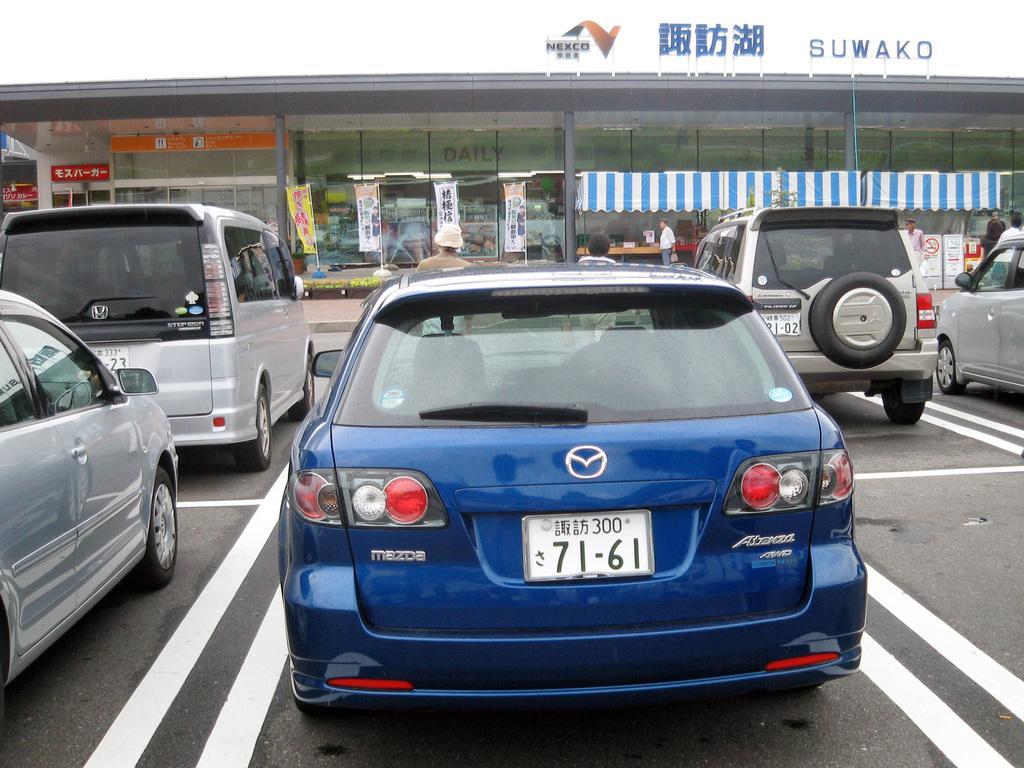In one or two sentences, can you explain what this image depicts? In this picture I can see there are few vehicles parked and there is a building in the backdrop, with a name board, poles with flags and the sky is clear. 